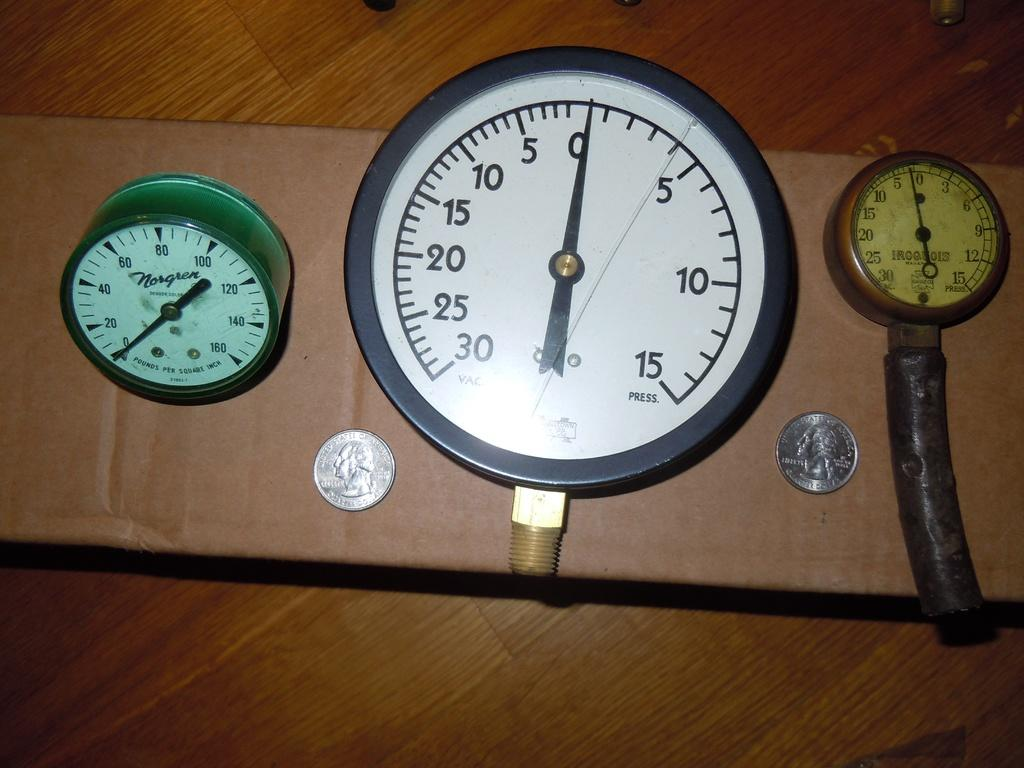<image>
Describe the image concisely. Old clock that has both hands on the number 0 in between two coins. 